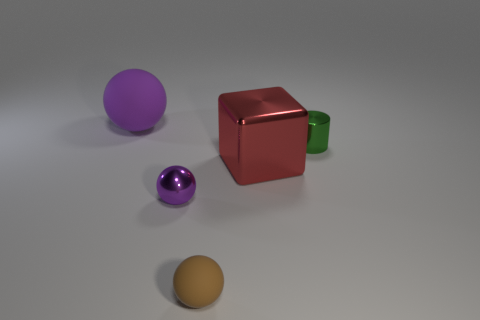The green thing that is made of the same material as the block is what shape?
Your answer should be very brief. Cylinder. What is the material of the tiny object behind the metallic object to the left of the brown ball?
Keep it short and to the point. Metal. There is a tiny metallic object left of the brown rubber sphere; is it the same shape as the brown object?
Offer a terse response. Yes. Is the number of rubber things behind the tiny matte object greater than the number of large blue metallic blocks?
Offer a very short reply. Yes. The large matte object that is the same color as the metal ball is what shape?
Offer a terse response. Sphere. What number of spheres are either big rubber things or big metal objects?
Offer a terse response. 1. The rubber ball to the right of the purple object in front of the red metal thing is what color?
Your answer should be very brief. Brown. There is a tiny shiny ball; is it the same color as the ball to the left of the purple metal ball?
Provide a succinct answer. Yes. What size is the ball that is the same material as the red cube?
Your response must be concise. Small. There is a thing that is the same color as the big rubber ball; what size is it?
Ensure brevity in your answer.  Small. 